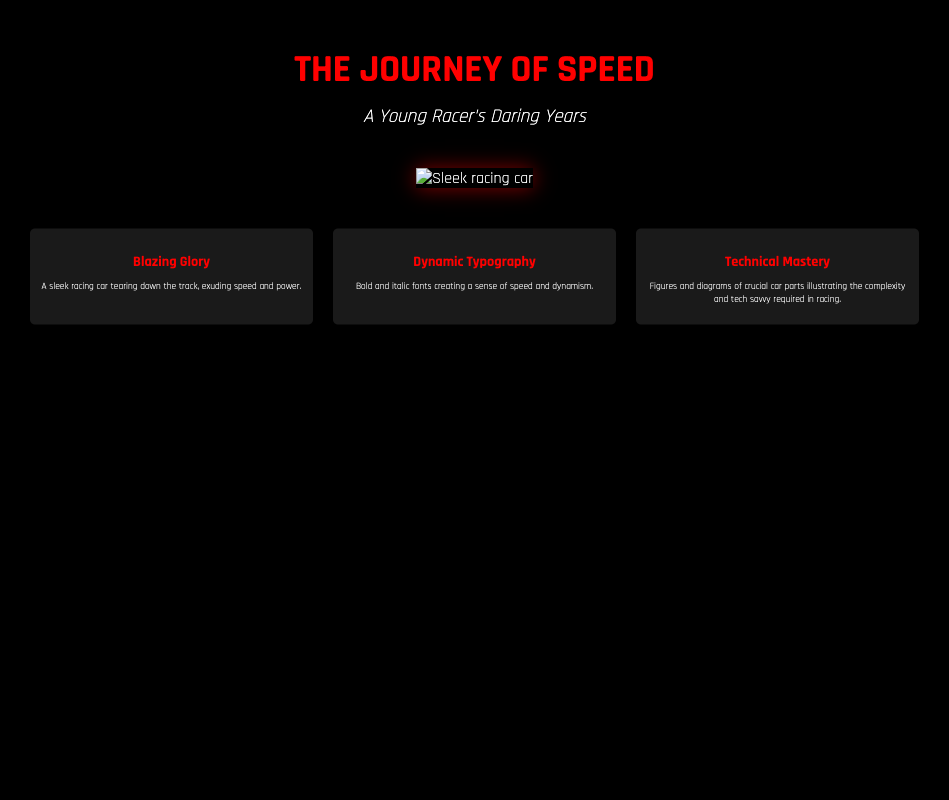What is the title of the book? The title of the book is prominently displayed on the cover in large typography.
Answer: The Journey of Speed What is the subtitle of the book? The subtitle provides additional context about the content of the book.
Answer: A Young Racer's Daring Years What is featured prominently in the center of the cover? The illustration or image that catches the viewer's eye is located in a specific area of the cover.
Answer: A sleek racing car What color is the title text? The title text has a specific color that makes it stand out against the background.
Answer: Red What type of images are in the background? The background images add context to the theme of the book.
Answer: Technical drawings of car parts What is the main theme of the key elements? Each key element summarizes a key aspect of the book's content, focusing on racing elements.
Answer: Speed and technology How is the typography described in the document? The typography is designed to reflect the motion and excitement inherent to racing.
Answer: Dynamic What is the background color of the book cover? The background color supports the overall design and mood of the cover.
Answer: Black What is the opacity of the technical drawings overlay? The opacity helps create a layered visual effect on the cover.
Answer: 0.3 